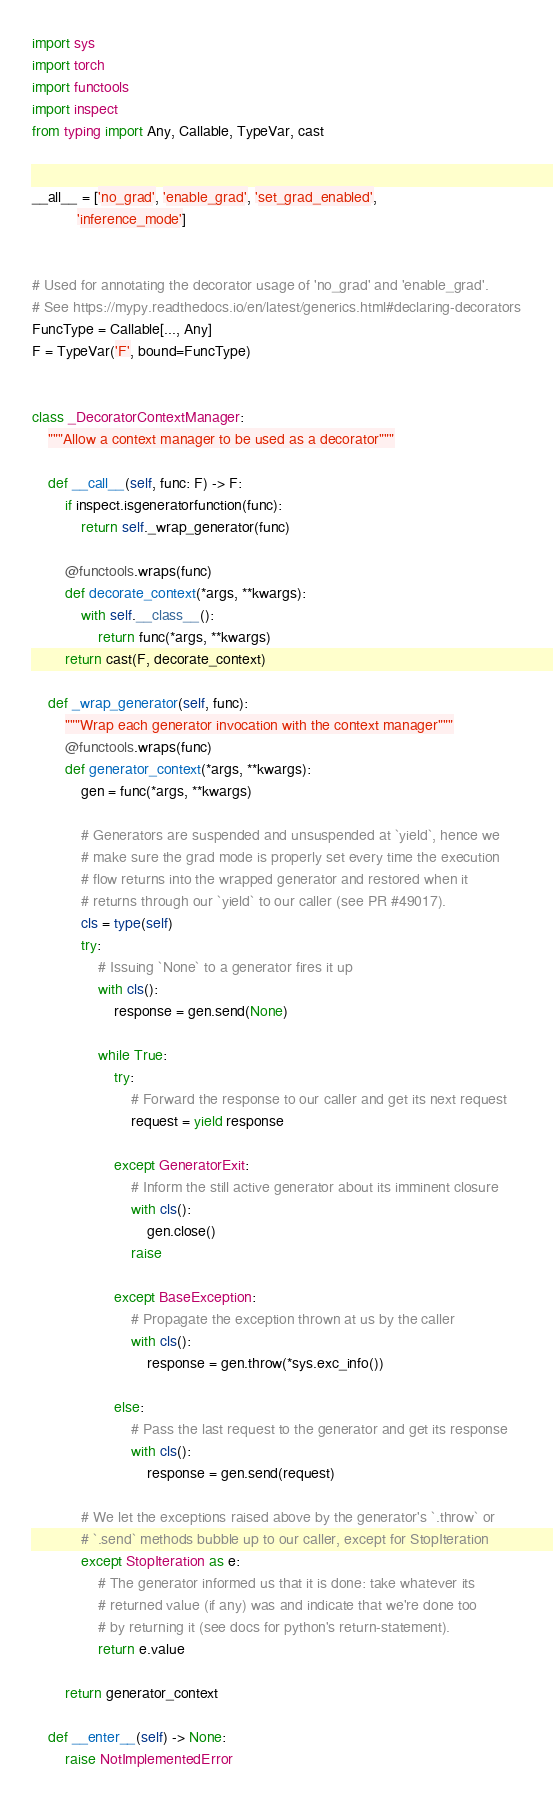Convert code to text. <code><loc_0><loc_0><loc_500><loc_500><_Python_>import sys
import torch
import functools
import inspect
from typing import Any, Callable, TypeVar, cast


__all__ = ['no_grad', 'enable_grad', 'set_grad_enabled',
           'inference_mode']


# Used for annotating the decorator usage of 'no_grad' and 'enable_grad'.
# See https://mypy.readthedocs.io/en/latest/generics.html#declaring-decorators
FuncType = Callable[..., Any]
F = TypeVar('F', bound=FuncType)


class _DecoratorContextManager:
    """Allow a context manager to be used as a decorator"""

    def __call__(self, func: F) -> F:
        if inspect.isgeneratorfunction(func):
            return self._wrap_generator(func)

        @functools.wraps(func)
        def decorate_context(*args, **kwargs):
            with self.__class__():
                return func(*args, **kwargs)
        return cast(F, decorate_context)

    def _wrap_generator(self, func):
        """Wrap each generator invocation with the context manager"""
        @functools.wraps(func)
        def generator_context(*args, **kwargs):
            gen = func(*args, **kwargs)

            # Generators are suspended and unsuspended at `yield`, hence we
            # make sure the grad mode is properly set every time the execution
            # flow returns into the wrapped generator and restored when it
            # returns through our `yield` to our caller (see PR #49017).
            cls = type(self)
            try:
                # Issuing `None` to a generator fires it up
                with cls():
                    response = gen.send(None)

                while True:
                    try:
                        # Forward the response to our caller and get its next request
                        request = yield response

                    except GeneratorExit:
                        # Inform the still active generator about its imminent closure
                        with cls():
                            gen.close()
                        raise

                    except BaseException:
                        # Propagate the exception thrown at us by the caller
                        with cls():
                            response = gen.throw(*sys.exc_info())

                    else:
                        # Pass the last request to the generator and get its response
                        with cls():
                            response = gen.send(request)

            # We let the exceptions raised above by the generator's `.throw` or
            # `.send` methods bubble up to our caller, except for StopIteration
            except StopIteration as e:
                # The generator informed us that it is done: take whatever its
                # returned value (if any) was and indicate that we're done too
                # by returning it (see docs for python's return-statement).
                return e.value

        return generator_context

    def __enter__(self) -> None:
        raise NotImplementedError
</code> 